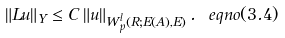Convert formula to latex. <formula><loc_0><loc_0><loc_500><loc_500>\left \| L u \right \| _ { Y } \leq C \left \| u \right \| _ { W _ { p } ^ { l } \left ( R ; E \left ( A \right ) , E \right ) } . \ e q n o ( 3 . 4 )</formula> 